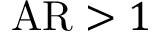<formula> <loc_0><loc_0><loc_500><loc_500>A R > 1</formula> 